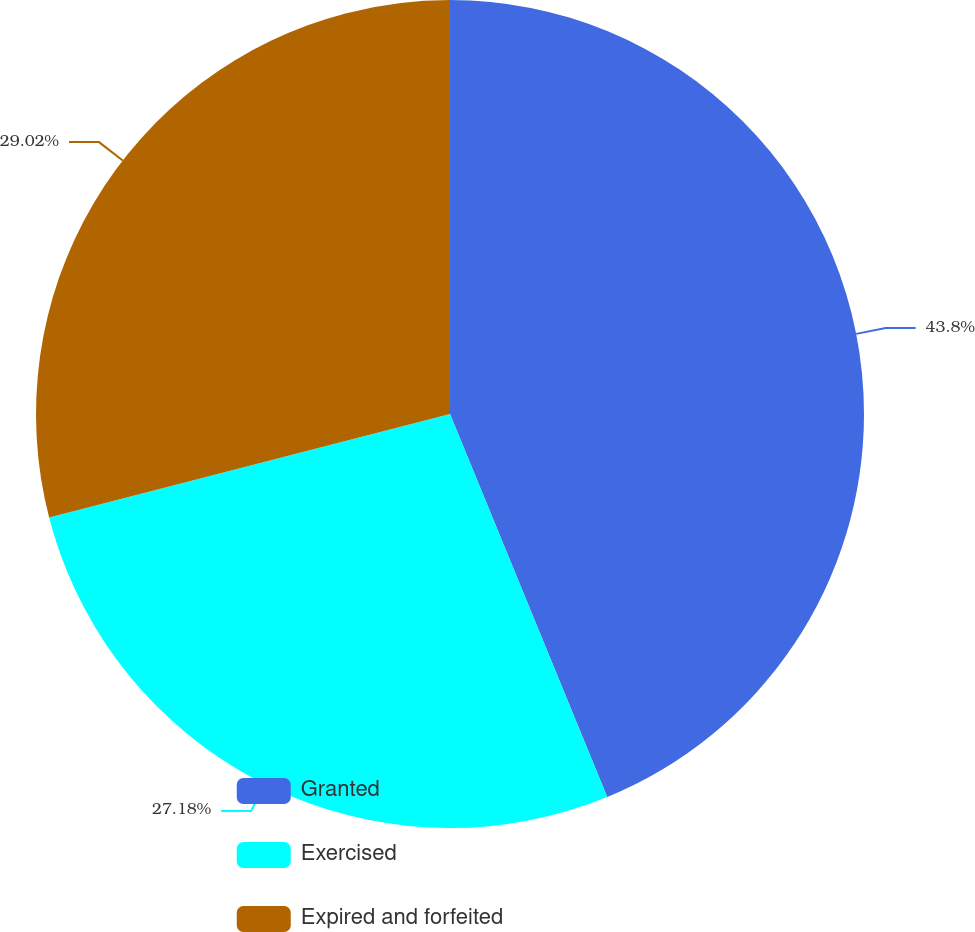<chart> <loc_0><loc_0><loc_500><loc_500><pie_chart><fcel>Granted<fcel>Exercised<fcel>Expired and forfeited<nl><fcel>43.8%<fcel>27.18%<fcel>29.02%<nl></chart> 